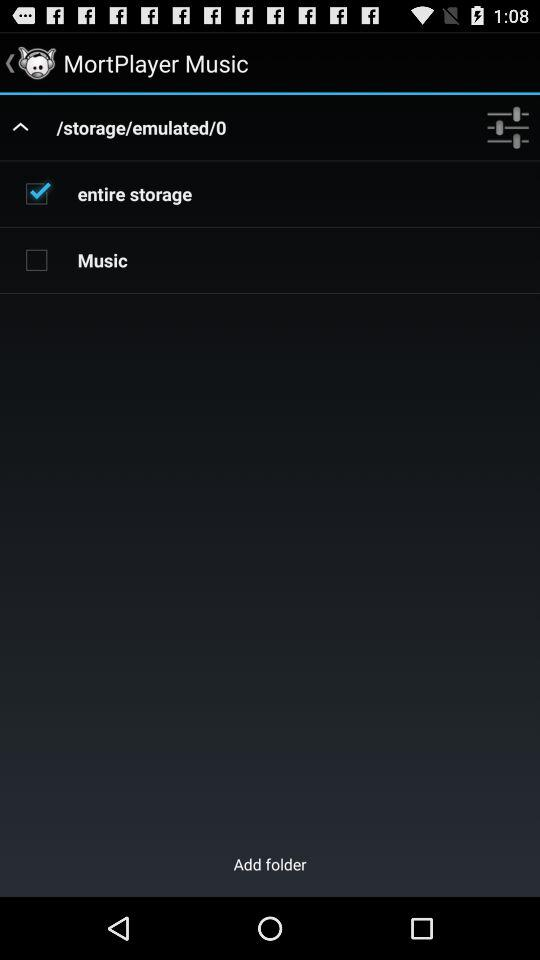What is the selected checkbox? The selected checkbox is "entire storage". 